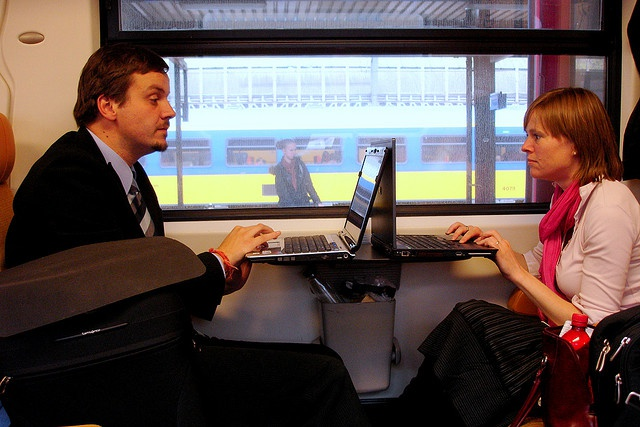Describe the objects in this image and their specific colors. I can see train in tan, white, black, lightblue, and khaki tones, people in tan, black, maroon, red, and brown tones, people in tan, black, maroon, and brown tones, train in tan, khaki, lightblue, and darkgray tones, and suitcase in tan, black, maroon, gray, and darkgray tones in this image. 